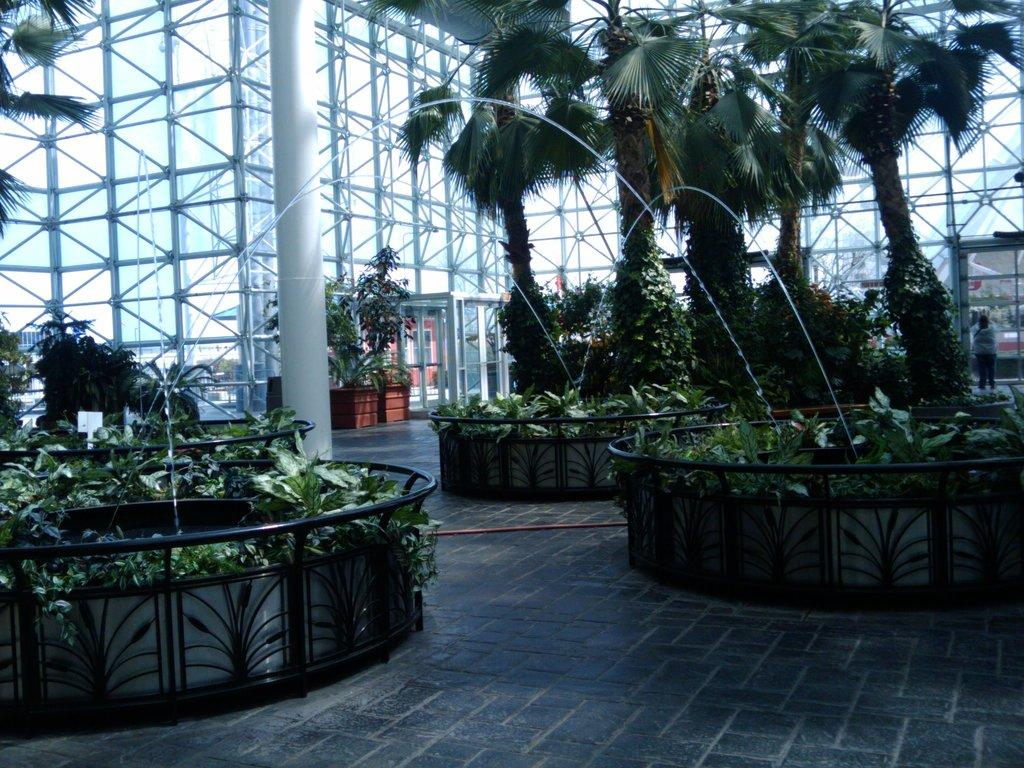What type of plants can be seen in the image? There are houseplants in the image. What architectural feature is present in the image? There is a fence in the image. What water feature can be seen in the image? There is a fountain in the image. What type of support structure is present in the image? There are pillars in the image. What type of material is used for some of the structures in the image? There are metal rods in the image. What type of entrance or exit can be seen in the image? There are doors in the image. What type of natural vegetation is present in the image? There are trees in the image. Who or what is present in the image? There is a group of people in the image. Can you describe the setting where the image was taken? The image may have been taken in a building. How many masses are being held in the image? There is no indication of a mass or any religious gathering in the image. What type of tree is being attacked by the group of people in the image? There is no tree or any indication of an attack in the image. 